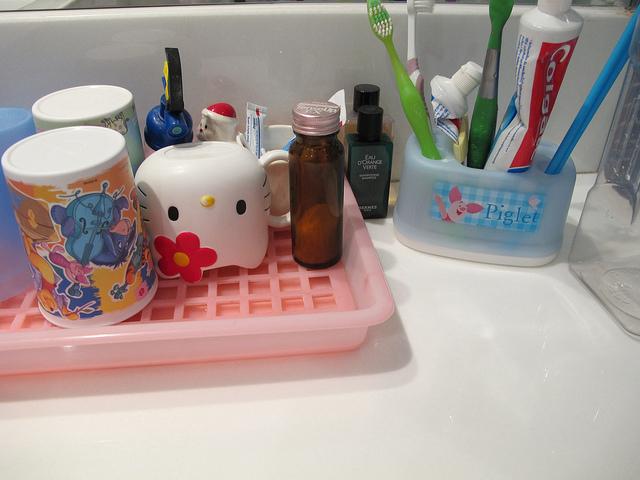Do these people squeeze from the bottom of the tube?
Write a very short answer. No. What Winnie the pooh character is in this picture?
Answer briefly. Piglet. Why is there so many cups?
Answer briefly. For rinsing. 